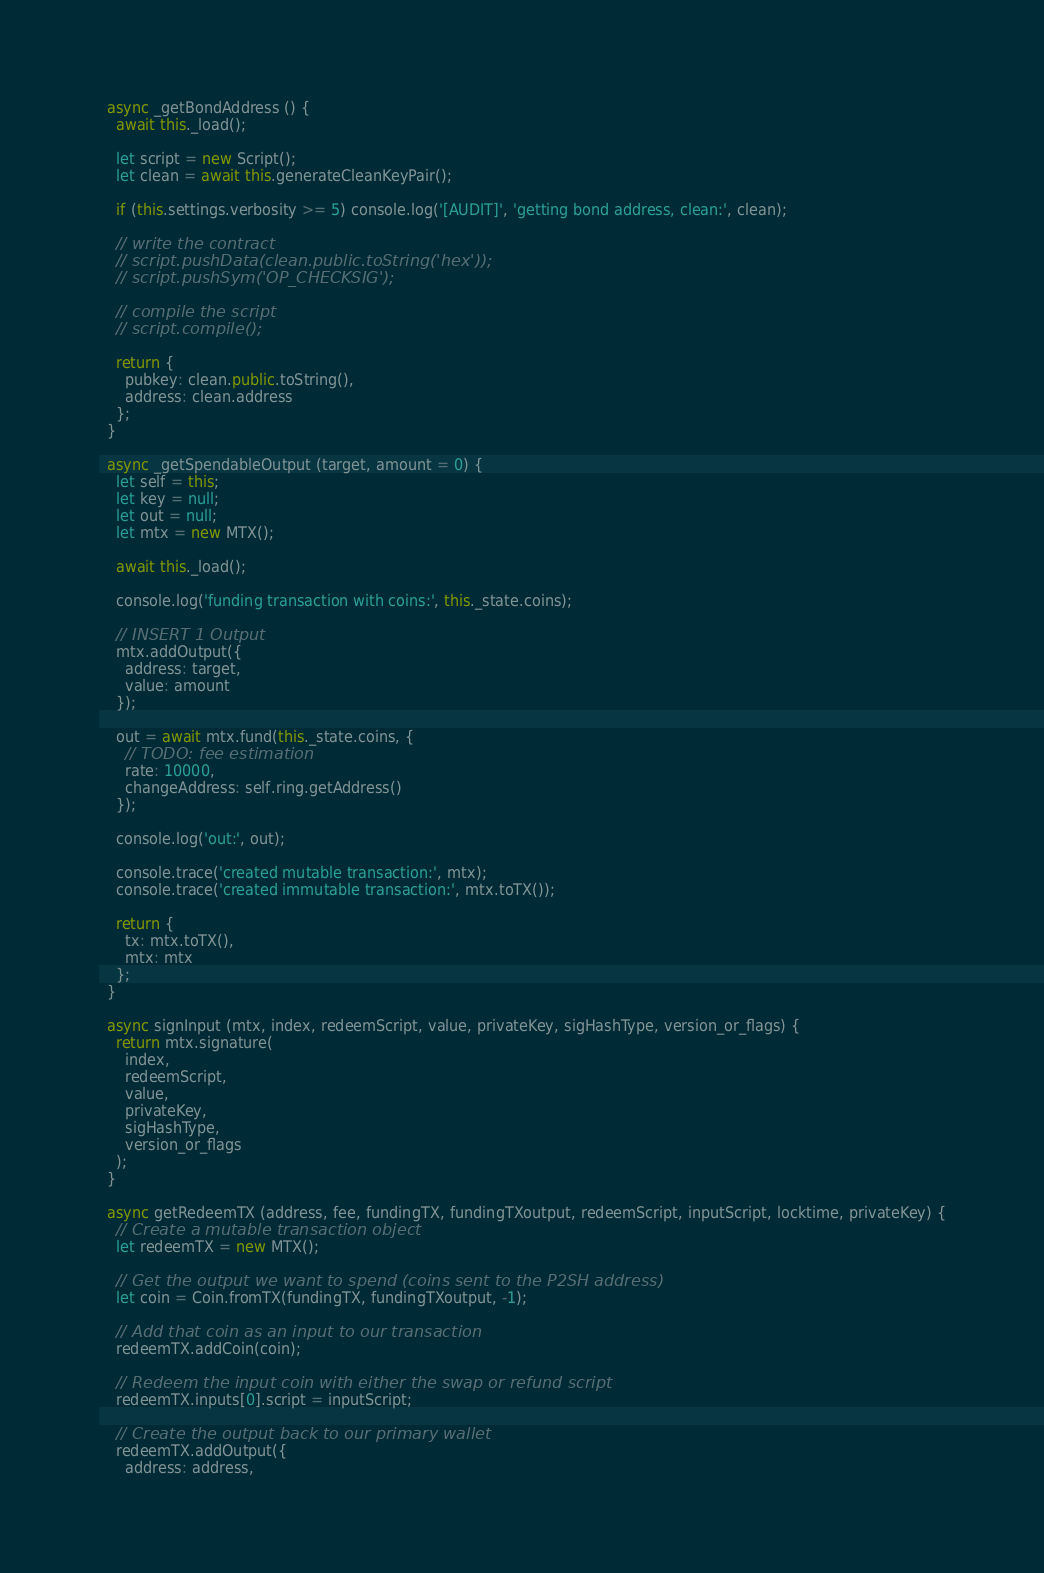<code> <loc_0><loc_0><loc_500><loc_500><_JavaScript_>  async _getBondAddress () {
    await this._load();

    let script = new Script();
    let clean = await this.generateCleanKeyPair();

    if (this.settings.verbosity >= 5) console.log('[AUDIT]', 'getting bond address, clean:', clean);

    // write the contract
    // script.pushData(clean.public.toString('hex'));
    // script.pushSym('OP_CHECKSIG');

    // compile the script
    // script.compile();

    return {
      pubkey: clean.public.toString(),
      address: clean.address
    };
  }

  async _getSpendableOutput (target, amount = 0) {
    let self = this;
    let key = null;
    let out = null;
    let mtx = new MTX();

    await this._load();

    console.log('funding transaction with coins:', this._state.coins);

    // INSERT 1 Output
    mtx.addOutput({
      address: target,
      value: amount
    });

    out = await mtx.fund(this._state.coins, {
      // TODO: fee estimation
      rate: 10000,
      changeAddress: self.ring.getAddress()
    });

    console.log('out:', out);

    console.trace('created mutable transaction:', mtx);
    console.trace('created immutable transaction:', mtx.toTX());

    return {
      tx: mtx.toTX(),
      mtx: mtx
    };
  }

  async signInput (mtx, index, redeemScript, value, privateKey, sigHashType, version_or_flags) {
    return mtx.signature(
      index,
      redeemScript,
      value,
      privateKey,
      sigHashType,
      version_or_flags
    );
  }

  async getRedeemTX (address, fee, fundingTX, fundingTXoutput, redeemScript, inputScript, locktime, privateKey) {
    // Create a mutable transaction object
    let redeemTX = new MTX();

    // Get the output we want to spend (coins sent to the P2SH address) 
    let coin = Coin.fromTX(fundingTX, fundingTXoutput, -1);

    // Add that coin as an input to our transaction
    redeemTX.addCoin(coin);

    // Redeem the input coin with either the swap or refund script
    redeemTX.inputs[0].script = inputScript;

    // Create the output back to our primary wallet
    redeemTX.addOutput({
      address: address,</code> 